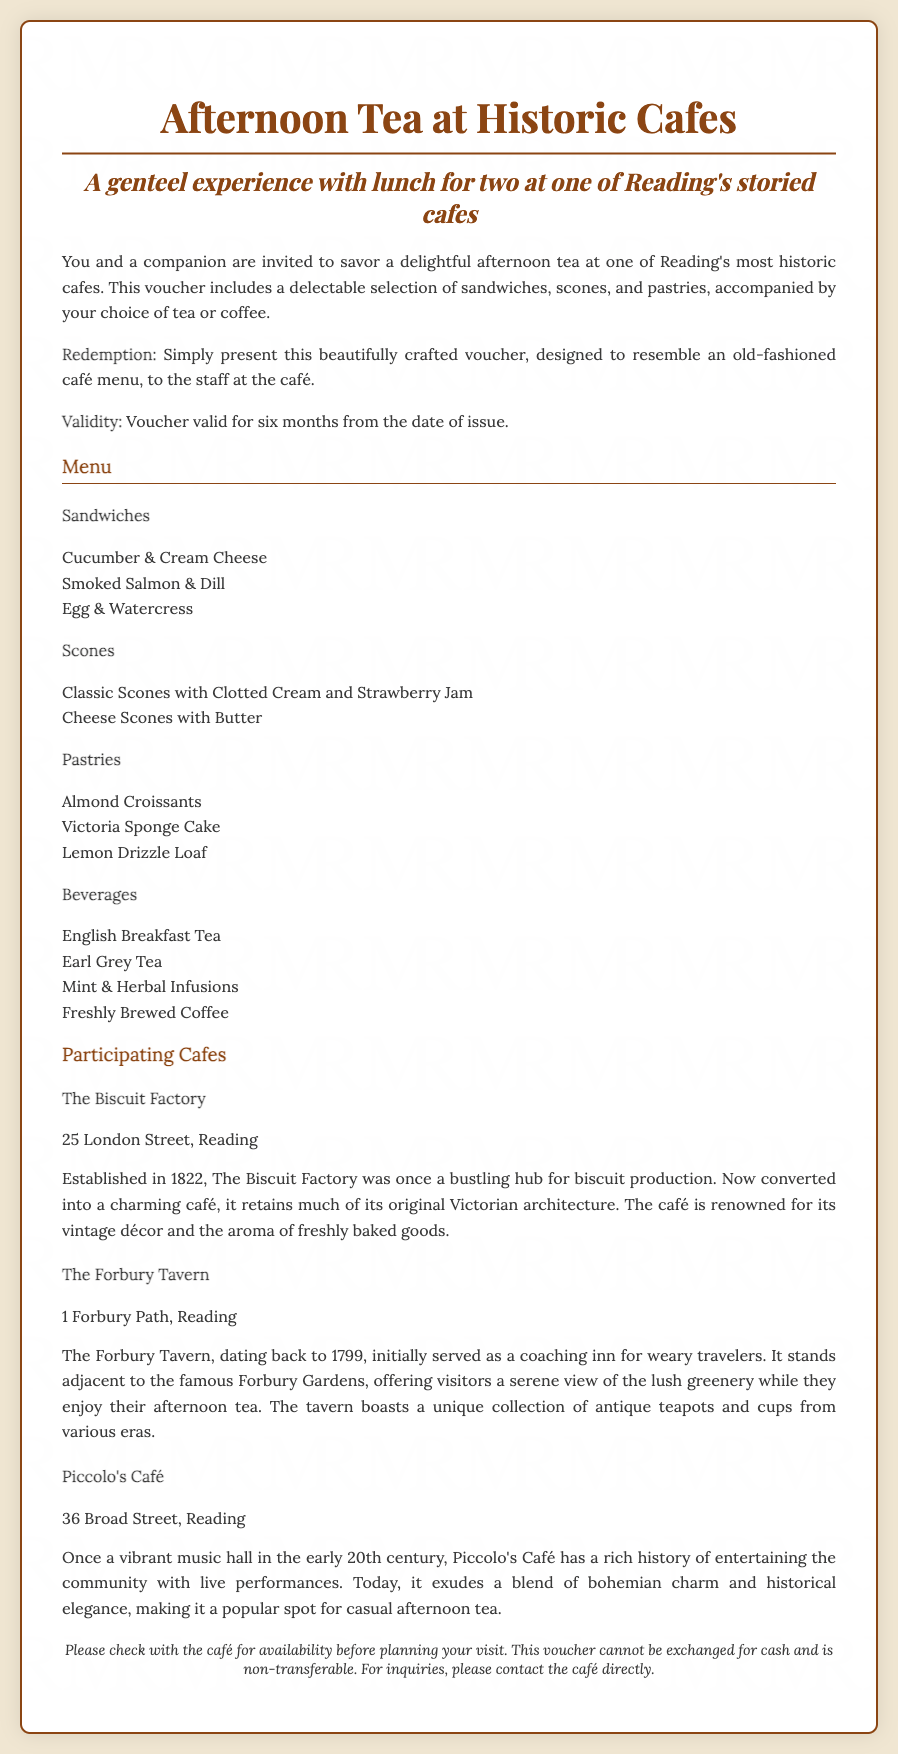What is the title of the voucher? The title of the voucher is prominently displayed at the top of the document.
Answer: Afternoon Tea at Historic Cafes How many cafes are participating? The document lists three specific cafes that are part of the offer.
Answer: Three What is the validity period of the voucher? The exact validity duration is mentioned in the details section of the voucher.
Answer: Six months What should you present to redeem the voucher? The document specifies that a crafted voucher should be given to the café staff for redemption.
Answer: This beautifully crafted voucher Where is The Biscuit Factory located? The address of The Biscuit Factory is clearly stated under its details in the document.
Answer: 25 London Street, Reading What year was The Forbury Tavern established? The establishment year for The Forbury Tavern is mentioned in the historical context provided.
Answer: 1799 What type of beverages are offered? A list of beverage options is provided within the menu section of the document.
Answer: English Breakfast Tea, Earl Grey Tea, Mint & Herbal Infusions, Freshly Brewed Coffee What kind of scones are included in the menu? Different types of scones are listed under the menu section, specifically mentioning their flavors.
Answer: Classic Scones with Clotted Cream and Strawberry Jam, Cheese Scones with Butter Can the voucher be exchanged for cash? The terms regarding the voucher's exchangeability are stated at the end.
Answer: No 